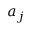<formula> <loc_0><loc_0><loc_500><loc_500>a _ { j }</formula> 